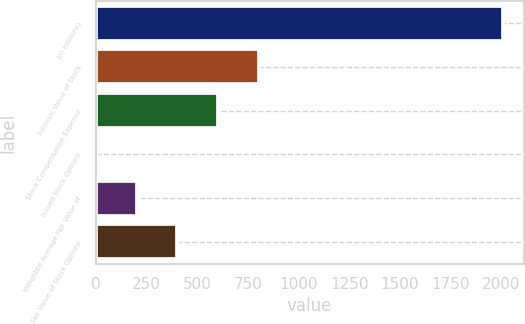Convert chart to OTSL. <chart><loc_0><loc_0><loc_500><loc_500><bar_chart><fcel>(in millions)<fcel>Intrinsic Value of Stock<fcel>Stock Compensation Expense<fcel>Issued Stock Options<fcel>Weighted Average Fair Value of<fcel>Fair Value of Stock Options<nl><fcel>2010<fcel>804.72<fcel>603.84<fcel>1.2<fcel>202.08<fcel>402.96<nl></chart> 